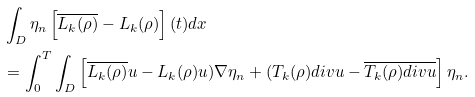<formula> <loc_0><loc_0><loc_500><loc_500>& \int _ { D } \eta _ { n } \left [ \overline { L _ { k } ( \rho ) } - L _ { k } ( \rho ) \right ] ( t ) d x \\ & = \int ^ { T } _ { 0 } \int _ { D } \left [ \overline { L _ { k } ( \rho ) } u - L _ { k } ( \rho ) u ) \nabla \eta _ { n } + ( T _ { k } ( \rho ) d i v u - \overline { T _ { k } ( \rho ) d i v u } \right ] \eta _ { n } .</formula> 